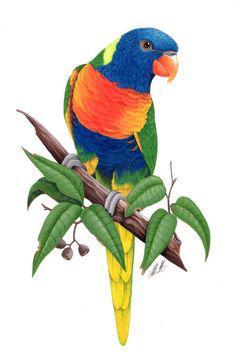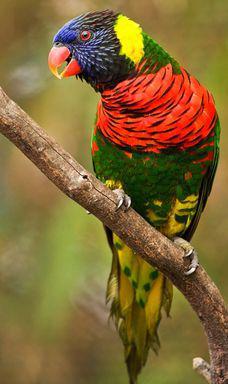The first image is the image on the left, the second image is the image on the right. Assess this claim about the two images: "A single bird perches on a branch with leaves on it.". Correct or not? Answer yes or no. Yes. The first image is the image on the left, the second image is the image on the right. Evaluate the accuracy of this statement regarding the images: "The parrots in the two images are looking toward each other.". Is it true? Answer yes or no. Yes. 